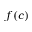Convert formula to latex. <formula><loc_0><loc_0><loc_500><loc_500>f ( c )</formula> 